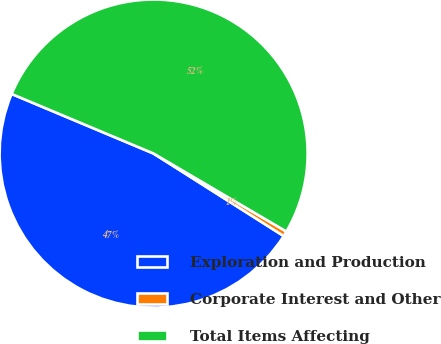Convert chart. <chart><loc_0><loc_0><loc_500><loc_500><pie_chart><fcel>Exploration and Production<fcel>Corporate Interest and Other<fcel>Total Items Affecting<nl><fcel>47.33%<fcel>0.54%<fcel>52.13%<nl></chart> 